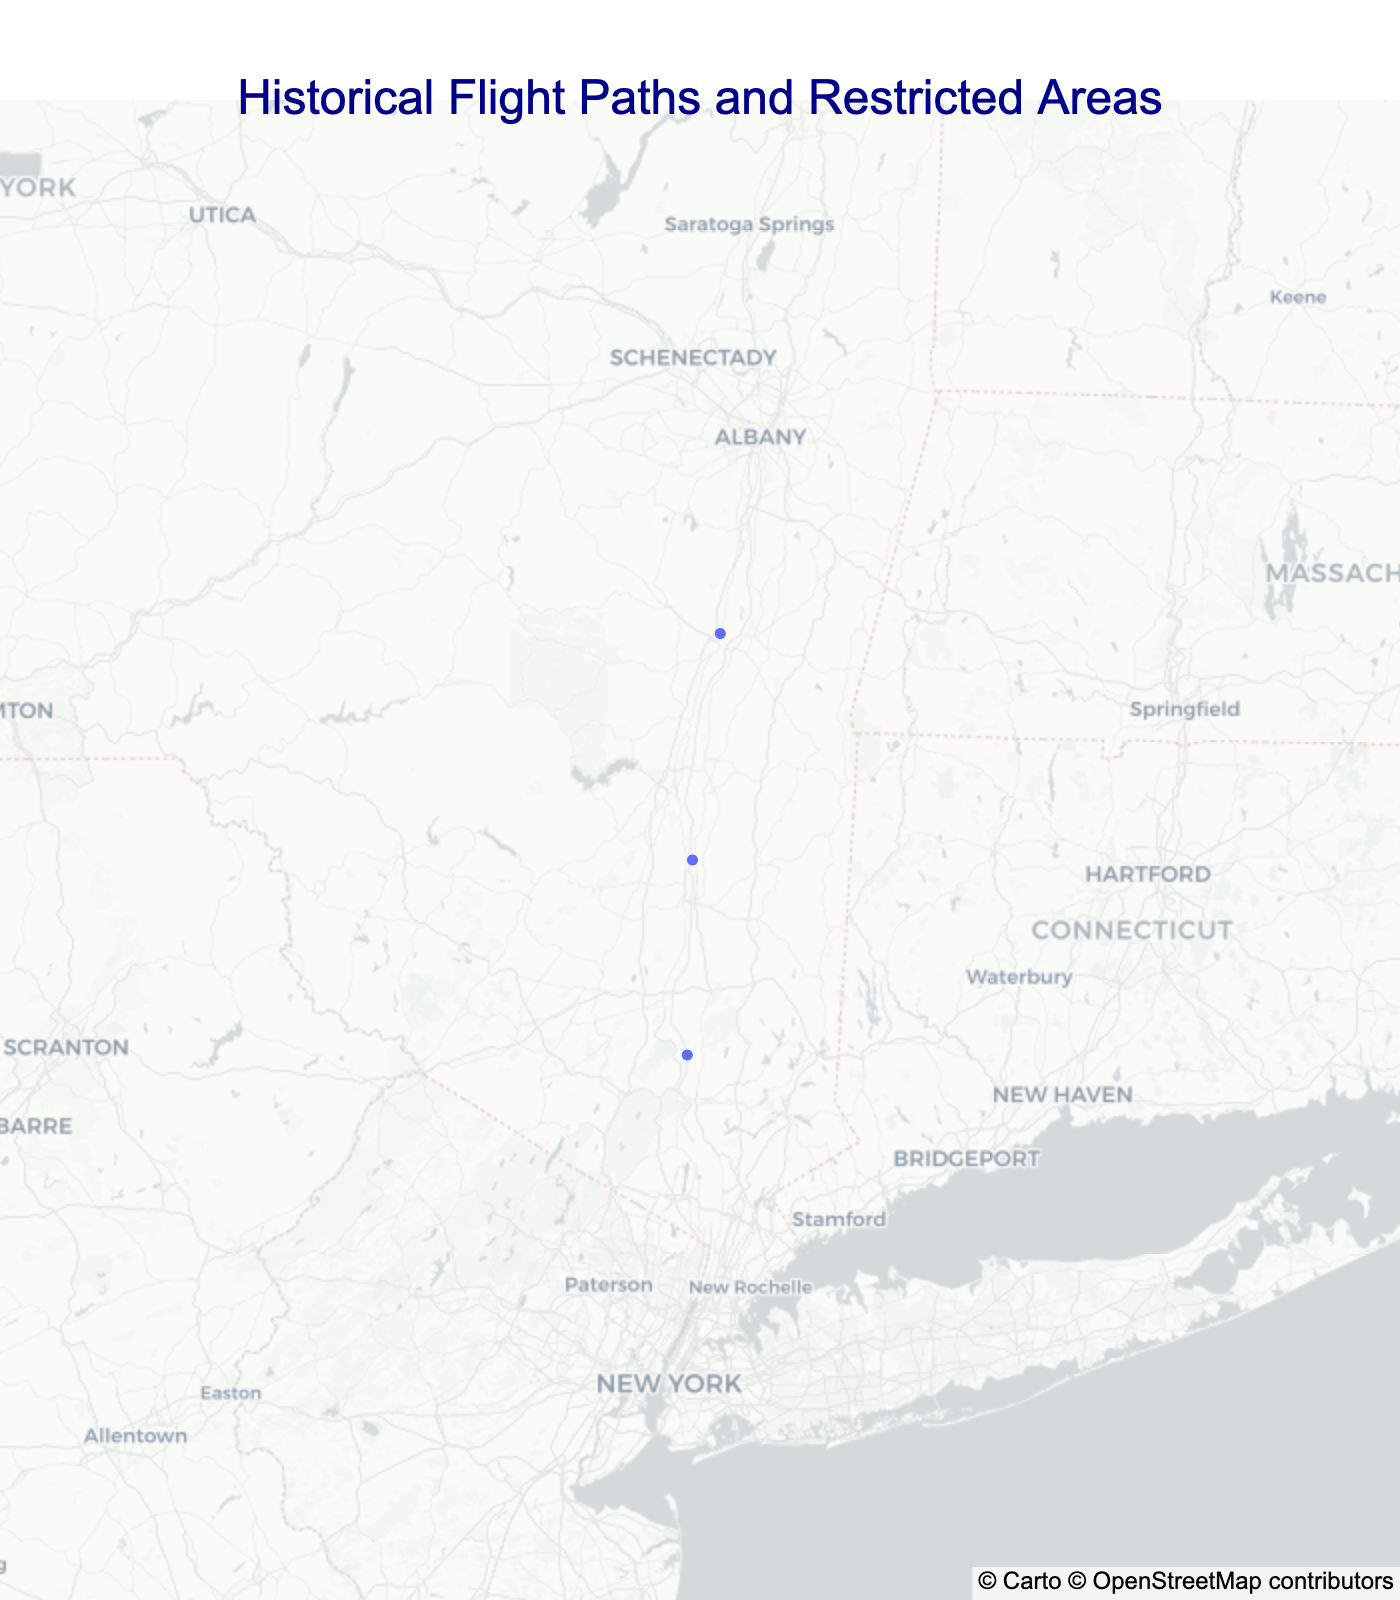What is the title of the map? The title of the map is located at the top of the figure, displaying the main subject of the map.
Answer: Historical Flight Paths and Restricted Areas How many types of routes or areas are plotted on the map? The map includes different markers for each type of route or area. By observing the legend marker styles and colors, one can determine the types.
Answer: Two What color represents historical routes on the map? The map uses different colors to distinguish between types. For historical routes, the color is consistent throughout the data points and legend.
Answer: Royal blue Which data point on the map represents a restricted area? By referring to the map's legend and color scheme, the restricted area is marked differently than historical routes.
Answer: West Point Restricted Zone How many historical routes are there on the map? The map depicts different routes using markers and varying colors. By counting the unique markers of the specified type, we can determine the number.
Answer: Two What is the geographical center of all mapped points? The geographical center (mean latitude and longitude) is calculated to position the map optimally.
Answer: Latitude: approximately 41.8123, Longitude: approximately -73.9211 Which historical route was established the earliest, and what is its year? By examining the data point labels and notes, the earliest date can be identified.
Answer: Catskill Flight Path, 1930 Is the West Point Restricted Zone closer to the Catskill Flight Path or the Hudson River Corridor? By comparing the proximity of the points on the map, the relative distances can be assessed.
Answer: Hudson River Corridor Between the historical routes plotted, which one is more northernly located? By comparing the latitude coordinates of the plotted historical routes, the one with the higher latitude is identified.
Answer: Catskill Flight Path What route runs along a scenic feature, and what is that feature? The map points have additional descriptive notes, and properties associated with each. By examining these notes, specific attributes can be discerned.
Answer: Hudson River Corridor, Hudson River 